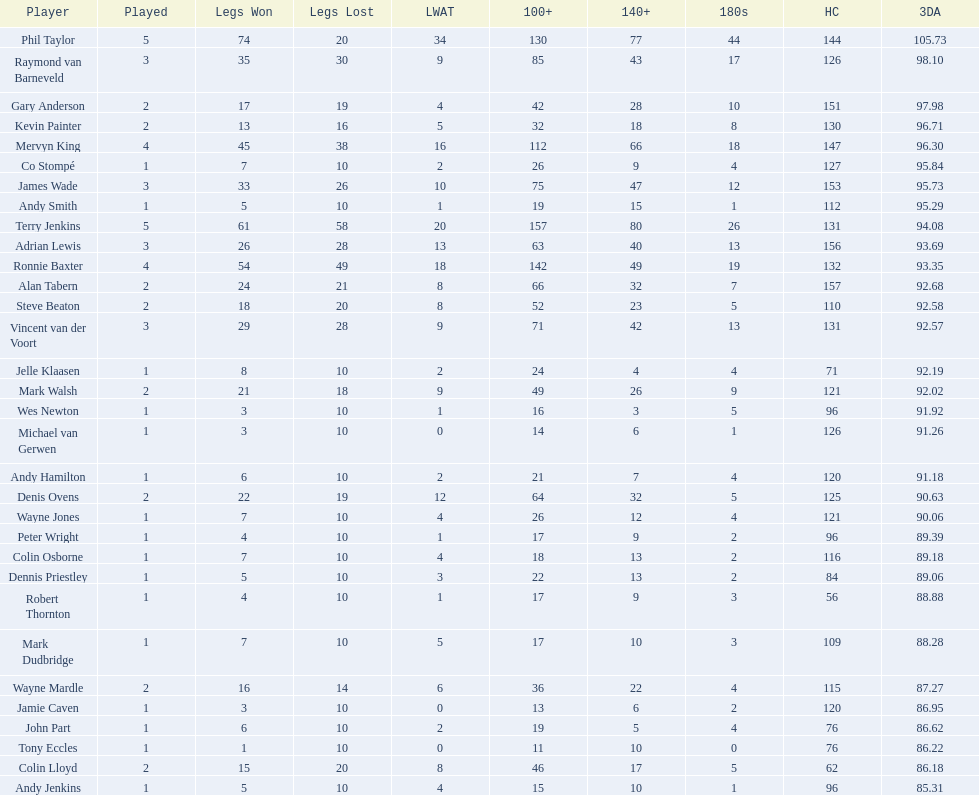Write the full table. {'header': ['Player', 'Played', 'Legs Won', 'Legs Lost', 'LWAT', '100+', '140+', '180s', 'HC', '3DA'], 'rows': [['Phil Taylor', '5', '74', '20', '34', '130', '77', '44', '144', '105.73'], ['Raymond van Barneveld', '3', '35', '30', '9', '85', '43', '17', '126', '98.10'], ['Gary Anderson', '2', '17', '19', '4', '42', '28', '10', '151', '97.98'], ['Kevin Painter', '2', '13', '16', '5', '32', '18', '8', '130', '96.71'], ['Mervyn King', '4', '45', '38', '16', '112', '66', '18', '147', '96.30'], ['Co Stompé', '1', '7', '10', '2', '26', '9', '4', '127', '95.84'], ['James Wade', '3', '33', '26', '10', '75', '47', '12', '153', '95.73'], ['Andy Smith', '1', '5', '10', '1', '19', '15', '1', '112', '95.29'], ['Terry Jenkins', '5', '61', '58', '20', '157', '80', '26', '131', '94.08'], ['Adrian Lewis', '3', '26', '28', '13', '63', '40', '13', '156', '93.69'], ['Ronnie Baxter', '4', '54', '49', '18', '142', '49', '19', '132', '93.35'], ['Alan Tabern', '2', '24', '21', '8', '66', '32', '7', '157', '92.68'], ['Steve Beaton', '2', '18', '20', '8', '52', '23', '5', '110', '92.58'], ['Vincent van der Voort', '3', '29', '28', '9', '71', '42', '13', '131', '92.57'], ['Jelle Klaasen', '1', '8', '10', '2', '24', '4', '4', '71', '92.19'], ['Mark Walsh', '2', '21', '18', '9', '49', '26', '9', '121', '92.02'], ['Wes Newton', '1', '3', '10', '1', '16', '3', '5', '96', '91.92'], ['Michael van Gerwen', '1', '3', '10', '0', '14', '6', '1', '126', '91.26'], ['Andy Hamilton', '1', '6', '10', '2', '21', '7', '4', '120', '91.18'], ['Denis Ovens', '2', '22', '19', '12', '64', '32', '5', '125', '90.63'], ['Wayne Jones', '1', '7', '10', '4', '26', '12', '4', '121', '90.06'], ['Peter Wright', '1', '4', '10', '1', '17', '9', '2', '96', '89.39'], ['Colin Osborne', '1', '7', '10', '4', '18', '13', '2', '116', '89.18'], ['Dennis Priestley', '1', '5', '10', '3', '22', '13', '2', '84', '89.06'], ['Robert Thornton', '1', '4', '10', '1', '17', '9', '3', '56', '88.88'], ['Mark Dudbridge', '1', '7', '10', '5', '17', '10', '3', '109', '88.28'], ['Wayne Mardle', '2', '16', '14', '6', '36', '22', '4', '115', '87.27'], ['Jamie Caven', '1', '3', '10', '0', '13', '6', '2', '120', '86.95'], ['John Part', '1', '6', '10', '2', '19', '5', '4', '76', '86.62'], ['Tony Eccles', '1', '1', '10', '0', '11', '10', '0', '76', '86.22'], ['Colin Lloyd', '2', '15', '20', '8', '46', '17', '5', '62', '86.18'], ['Andy Jenkins', '1', '5', '10', '4', '15', '10', '1', '96', '85.31']]} Mark walsh's average is above/below 93? Below. 